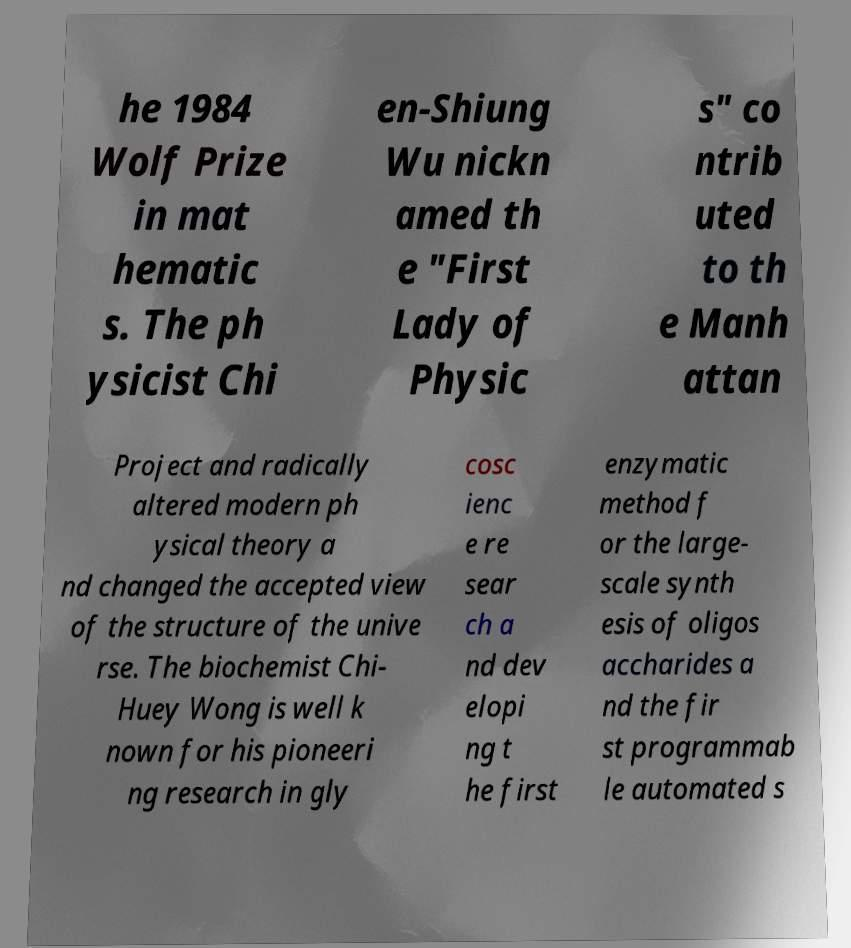Could you assist in decoding the text presented in this image and type it out clearly? he 1984 Wolf Prize in mat hematic s. The ph ysicist Chi en-Shiung Wu nickn amed th e "First Lady of Physic s" co ntrib uted to th e Manh attan Project and radically altered modern ph ysical theory a nd changed the accepted view of the structure of the unive rse. The biochemist Chi- Huey Wong is well k nown for his pioneeri ng research in gly cosc ienc e re sear ch a nd dev elopi ng t he first enzymatic method f or the large- scale synth esis of oligos accharides a nd the fir st programmab le automated s 